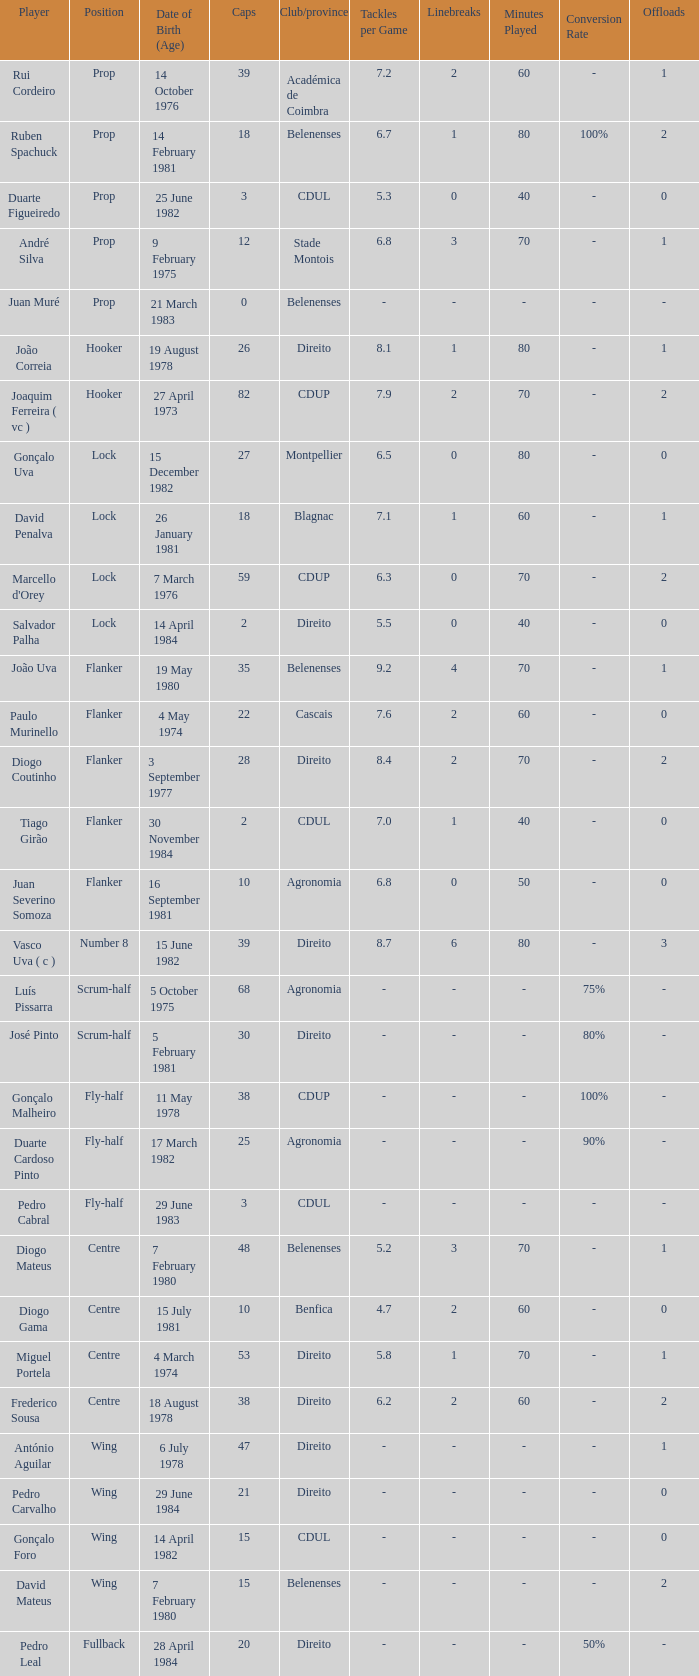How many caps have a Date of Birth (Age) of 15 july 1981? 1.0. 